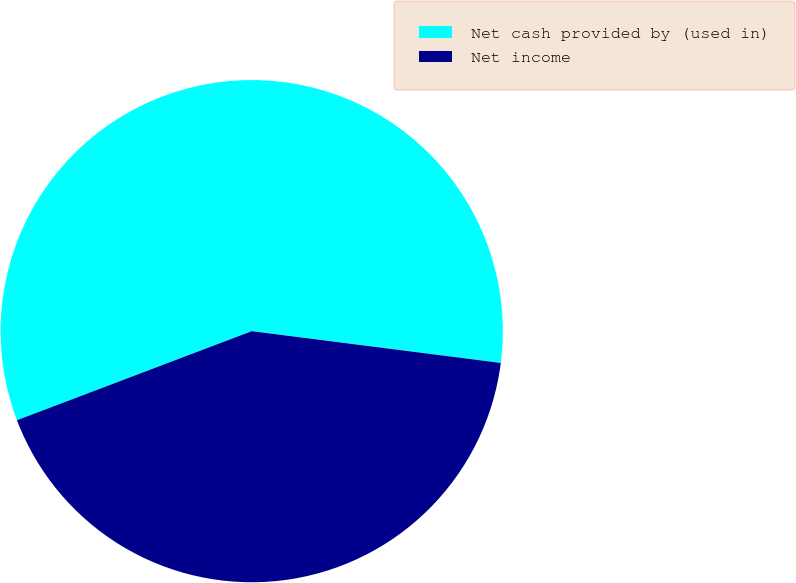Convert chart. <chart><loc_0><loc_0><loc_500><loc_500><pie_chart><fcel>Net cash provided by (used in)<fcel>Net income<nl><fcel>57.79%<fcel>42.21%<nl></chart> 